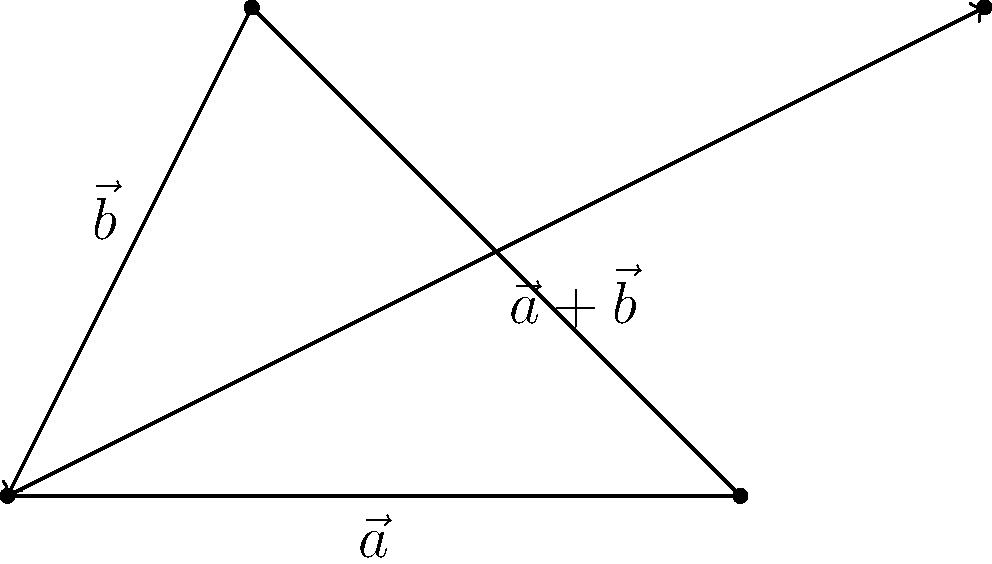In the parallelogram method of vector addition shown above, vector $\vec{a}$ has a magnitude of 3 units and vector $\vec{b}$ has a magnitude of $\sqrt{5}$ units. If the angle between these vectors is 60°, what is the magnitude of the resultant vector $\vec{a}+\vec{b}$? To find the magnitude of the resultant vector $\vec{a}+\vec{b}$, we can use the law of cosines:

1) Let $c$ be the magnitude of $\vec{a}+\vec{b}$. The law of cosines states:
   
   $$c^2 = a^2 + b^2 - 2ab \cos(\theta)$$

2) We know:
   $a = 3$
   $b = \sqrt{5}$
   $\theta = 60°$

3) Substituting these values:
   
   $$c^2 = 3^2 + (\sqrt{5})^2 - 2(3)(\sqrt{5}) \cos(60°)$$

4) Simplify:
   $$c^2 = 9 + 5 - 2(3)(\sqrt{5}) (\frac{1}{2})$$
   $$c^2 = 14 - 3\sqrt{5}$$

5) Take the square root of both sides:
   
   $$c = \sqrt{14 - 3\sqrt{5}}$$

This is the magnitude of the resultant vector $\vec{a}+\vec{b}$.
Answer: $\sqrt{14 - 3\sqrt{5}}$ 